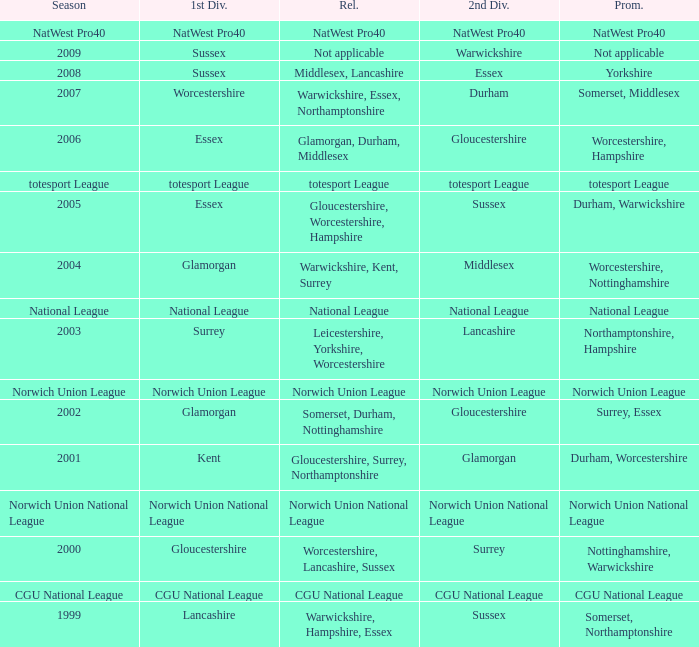What season was Norwich Union League promoted? Norwich Union League. 